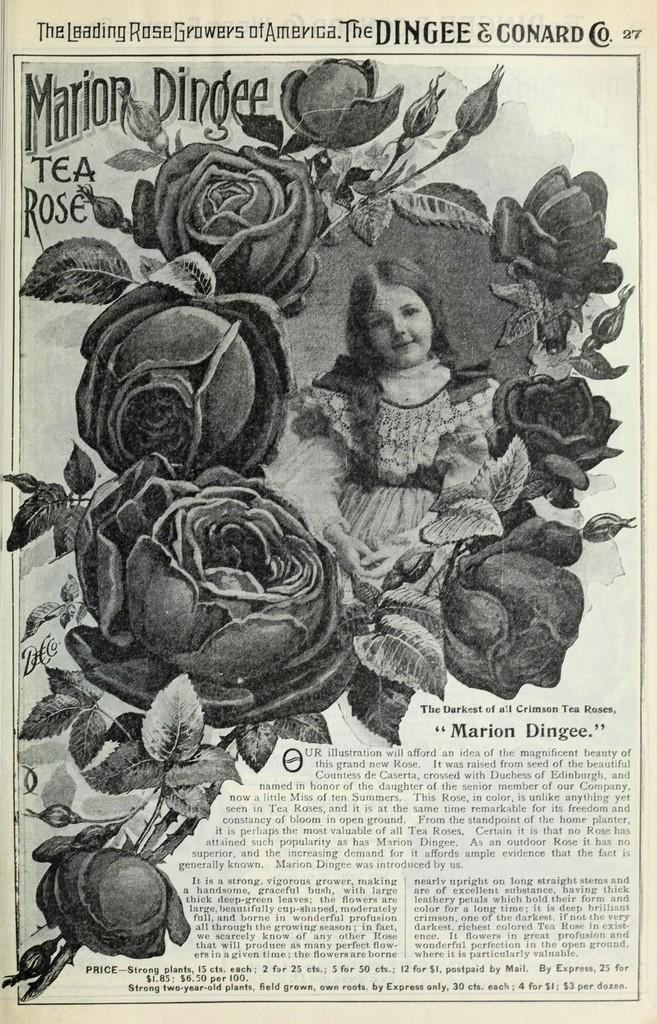What is the main subject of the poster in the image? The main subject of the poster in the image is a woman who is smiling. What can be seen on the right side of the poster? There is a paper with flower designs on the right side of the poster. Is there any text on the poster? Yes, there is a quotation in the bottom right corner of the poster. How many tomatoes are arranged in a circle on the poster? There are no tomatoes or circles present on the poster; it features a smiling woman, flower designs, and a quotation. 